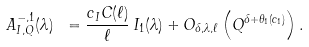<formula> <loc_0><loc_0><loc_500><loc_500>A _ { I , Q } ^ { - , 1 } ( \lambda ) \ = \frac { c _ { I } C ( \ell ) } { \ell } \, I _ { 1 } ( \lambda ) + O _ { \delta , \lambda , \ell } \left ( Q ^ { \delta + \theta _ { 1 } ( c _ { 1 } ) } \right ) .</formula> 